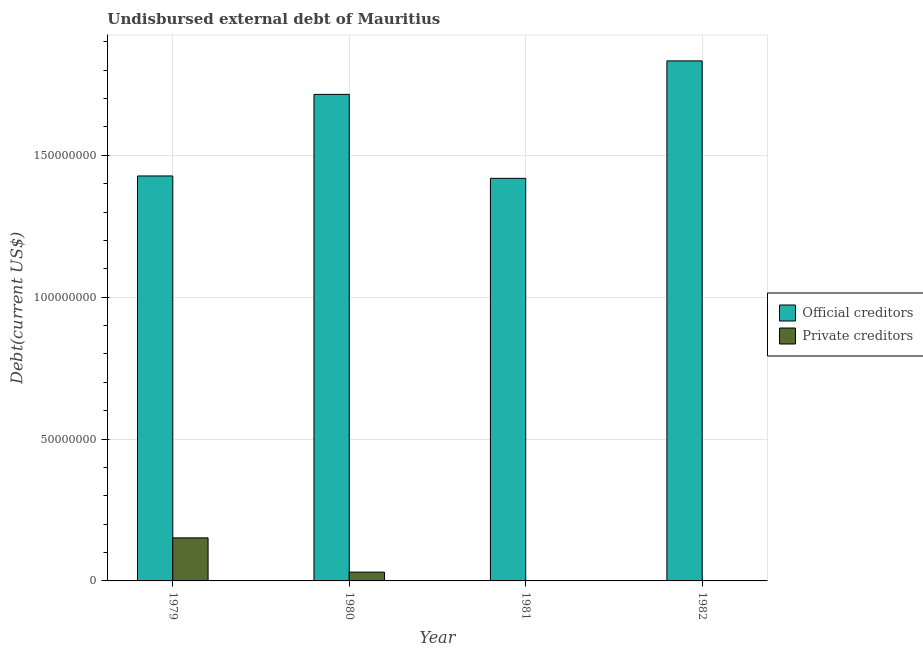How many different coloured bars are there?
Your answer should be compact. 2. Are the number of bars per tick equal to the number of legend labels?
Your answer should be compact. Yes. How many bars are there on the 1st tick from the left?
Offer a terse response. 2. How many bars are there on the 3rd tick from the right?
Provide a short and direct response. 2. What is the label of the 4th group of bars from the left?
Give a very brief answer. 1982. In how many cases, is the number of bars for a given year not equal to the number of legend labels?
Your response must be concise. 0. What is the undisbursed external debt of official creditors in 1981?
Offer a terse response. 1.42e+08. Across all years, what is the maximum undisbursed external debt of private creditors?
Your response must be concise. 1.52e+07. Across all years, what is the minimum undisbursed external debt of official creditors?
Your response must be concise. 1.42e+08. In which year was the undisbursed external debt of private creditors maximum?
Provide a short and direct response. 1979. In which year was the undisbursed external debt of private creditors minimum?
Give a very brief answer. 1982. What is the total undisbursed external debt of private creditors in the graph?
Provide a short and direct response. 1.83e+07. What is the difference between the undisbursed external debt of official creditors in 1979 and that in 1980?
Your answer should be compact. -2.88e+07. What is the difference between the undisbursed external debt of official creditors in 1980 and the undisbursed external debt of private creditors in 1982?
Your answer should be compact. -1.18e+07. What is the average undisbursed external debt of official creditors per year?
Make the answer very short. 1.60e+08. In the year 1979, what is the difference between the undisbursed external debt of official creditors and undisbursed external debt of private creditors?
Offer a very short reply. 0. In how many years, is the undisbursed external debt of private creditors greater than 60000000 US$?
Your response must be concise. 0. What is the ratio of the undisbursed external debt of private creditors in 1979 to that in 1981?
Give a very brief answer. 329.87. Is the undisbursed external debt of private creditors in 1981 less than that in 1982?
Offer a very short reply. No. Is the difference between the undisbursed external debt of private creditors in 1979 and 1980 greater than the difference between the undisbursed external debt of official creditors in 1979 and 1980?
Make the answer very short. No. What is the difference between the highest and the second highest undisbursed external debt of official creditors?
Provide a succinct answer. 1.18e+07. What is the difference between the highest and the lowest undisbursed external debt of official creditors?
Ensure brevity in your answer.  4.14e+07. In how many years, is the undisbursed external debt of private creditors greater than the average undisbursed external debt of private creditors taken over all years?
Offer a terse response. 1. Is the sum of the undisbursed external debt of official creditors in 1979 and 1980 greater than the maximum undisbursed external debt of private creditors across all years?
Your answer should be compact. Yes. What does the 1st bar from the left in 1981 represents?
Keep it short and to the point. Official creditors. What does the 2nd bar from the right in 1981 represents?
Your answer should be very brief. Official creditors. How many bars are there?
Offer a very short reply. 8. Are all the bars in the graph horizontal?
Offer a very short reply. No. How many years are there in the graph?
Offer a very short reply. 4. What is the difference between two consecutive major ticks on the Y-axis?
Your answer should be compact. 5.00e+07. Does the graph contain grids?
Offer a very short reply. Yes. How are the legend labels stacked?
Provide a short and direct response. Vertical. What is the title of the graph?
Provide a succinct answer. Undisbursed external debt of Mauritius. Does "Infant" appear as one of the legend labels in the graph?
Give a very brief answer. No. What is the label or title of the Y-axis?
Offer a terse response. Debt(current US$). What is the Debt(current US$) in Official creditors in 1979?
Your answer should be compact. 1.43e+08. What is the Debt(current US$) of Private creditors in 1979?
Keep it short and to the point. 1.52e+07. What is the Debt(current US$) of Official creditors in 1980?
Your response must be concise. 1.71e+08. What is the Debt(current US$) of Private creditors in 1980?
Ensure brevity in your answer.  3.10e+06. What is the Debt(current US$) of Official creditors in 1981?
Provide a short and direct response. 1.42e+08. What is the Debt(current US$) of Private creditors in 1981?
Your answer should be very brief. 4.60e+04. What is the Debt(current US$) of Official creditors in 1982?
Your answer should be very brief. 1.83e+08. What is the Debt(current US$) in Private creditors in 1982?
Ensure brevity in your answer.  1.90e+04. Across all years, what is the maximum Debt(current US$) of Official creditors?
Give a very brief answer. 1.83e+08. Across all years, what is the maximum Debt(current US$) in Private creditors?
Offer a terse response. 1.52e+07. Across all years, what is the minimum Debt(current US$) of Official creditors?
Give a very brief answer. 1.42e+08. Across all years, what is the minimum Debt(current US$) in Private creditors?
Offer a very short reply. 1.90e+04. What is the total Debt(current US$) of Official creditors in the graph?
Offer a terse response. 6.39e+08. What is the total Debt(current US$) in Private creditors in the graph?
Provide a succinct answer. 1.83e+07. What is the difference between the Debt(current US$) in Official creditors in 1979 and that in 1980?
Provide a succinct answer. -2.88e+07. What is the difference between the Debt(current US$) of Private creditors in 1979 and that in 1980?
Keep it short and to the point. 1.21e+07. What is the difference between the Debt(current US$) in Official creditors in 1979 and that in 1981?
Your response must be concise. 8.43e+05. What is the difference between the Debt(current US$) of Private creditors in 1979 and that in 1981?
Make the answer very short. 1.51e+07. What is the difference between the Debt(current US$) of Official creditors in 1979 and that in 1982?
Offer a terse response. -4.06e+07. What is the difference between the Debt(current US$) in Private creditors in 1979 and that in 1982?
Offer a very short reply. 1.52e+07. What is the difference between the Debt(current US$) of Official creditors in 1980 and that in 1981?
Your response must be concise. 2.96e+07. What is the difference between the Debt(current US$) of Private creditors in 1980 and that in 1981?
Your response must be concise. 3.06e+06. What is the difference between the Debt(current US$) in Official creditors in 1980 and that in 1982?
Your response must be concise. -1.18e+07. What is the difference between the Debt(current US$) of Private creditors in 1980 and that in 1982?
Offer a terse response. 3.08e+06. What is the difference between the Debt(current US$) of Official creditors in 1981 and that in 1982?
Your answer should be very brief. -4.14e+07. What is the difference between the Debt(current US$) of Private creditors in 1981 and that in 1982?
Offer a very short reply. 2.70e+04. What is the difference between the Debt(current US$) of Official creditors in 1979 and the Debt(current US$) of Private creditors in 1980?
Provide a short and direct response. 1.40e+08. What is the difference between the Debt(current US$) in Official creditors in 1979 and the Debt(current US$) in Private creditors in 1981?
Provide a succinct answer. 1.43e+08. What is the difference between the Debt(current US$) in Official creditors in 1979 and the Debt(current US$) in Private creditors in 1982?
Provide a short and direct response. 1.43e+08. What is the difference between the Debt(current US$) of Official creditors in 1980 and the Debt(current US$) of Private creditors in 1981?
Offer a terse response. 1.71e+08. What is the difference between the Debt(current US$) of Official creditors in 1980 and the Debt(current US$) of Private creditors in 1982?
Keep it short and to the point. 1.71e+08. What is the difference between the Debt(current US$) of Official creditors in 1981 and the Debt(current US$) of Private creditors in 1982?
Offer a very short reply. 1.42e+08. What is the average Debt(current US$) in Official creditors per year?
Provide a succinct answer. 1.60e+08. What is the average Debt(current US$) of Private creditors per year?
Your answer should be very brief. 4.59e+06. In the year 1979, what is the difference between the Debt(current US$) in Official creditors and Debt(current US$) in Private creditors?
Make the answer very short. 1.28e+08. In the year 1980, what is the difference between the Debt(current US$) in Official creditors and Debt(current US$) in Private creditors?
Provide a short and direct response. 1.68e+08. In the year 1981, what is the difference between the Debt(current US$) of Official creditors and Debt(current US$) of Private creditors?
Give a very brief answer. 1.42e+08. In the year 1982, what is the difference between the Debt(current US$) in Official creditors and Debt(current US$) in Private creditors?
Provide a short and direct response. 1.83e+08. What is the ratio of the Debt(current US$) in Official creditors in 1979 to that in 1980?
Make the answer very short. 0.83. What is the ratio of the Debt(current US$) of Private creditors in 1979 to that in 1980?
Provide a succinct answer. 4.89. What is the ratio of the Debt(current US$) in Official creditors in 1979 to that in 1981?
Keep it short and to the point. 1.01. What is the ratio of the Debt(current US$) in Private creditors in 1979 to that in 1981?
Your answer should be compact. 329.87. What is the ratio of the Debt(current US$) in Official creditors in 1979 to that in 1982?
Ensure brevity in your answer.  0.78. What is the ratio of the Debt(current US$) of Private creditors in 1979 to that in 1982?
Ensure brevity in your answer.  798.63. What is the ratio of the Debt(current US$) of Official creditors in 1980 to that in 1981?
Keep it short and to the point. 1.21. What is the ratio of the Debt(current US$) of Private creditors in 1980 to that in 1981?
Offer a terse response. 67.48. What is the ratio of the Debt(current US$) of Official creditors in 1980 to that in 1982?
Provide a short and direct response. 0.94. What is the ratio of the Debt(current US$) in Private creditors in 1980 to that in 1982?
Provide a succinct answer. 163.37. What is the ratio of the Debt(current US$) of Official creditors in 1981 to that in 1982?
Make the answer very short. 0.77. What is the ratio of the Debt(current US$) of Private creditors in 1981 to that in 1982?
Give a very brief answer. 2.42. What is the difference between the highest and the second highest Debt(current US$) in Official creditors?
Keep it short and to the point. 1.18e+07. What is the difference between the highest and the second highest Debt(current US$) of Private creditors?
Your answer should be compact. 1.21e+07. What is the difference between the highest and the lowest Debt(current US$) in Official creditors?
Ensure brevity in your answer.  4.14e+07. What is the difference between the highest and the lowest Debt(current US$) in Private creditors?
Ensure brevity in your answer.  1.52e+07. 